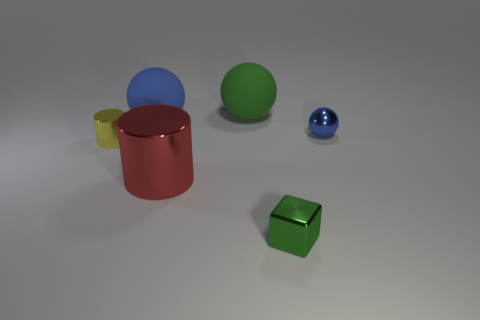Subtract 1 spheres. How many spheres are left? 2 Add 4 tiny green metallic objects. How many objects exist? 10 Subtract all cylinders. How many objects are left? 4 Subtract all tiny cyan rubber things. Subtract all big red metallic cylinders. How many objects are left? 5 Add 2 yellow objects. How many yellow objects are left? 3 Add 5 rubber objects. How many rubber objects exist? 7 Subtract 0 gray cylinders. How many objects are left? 6 